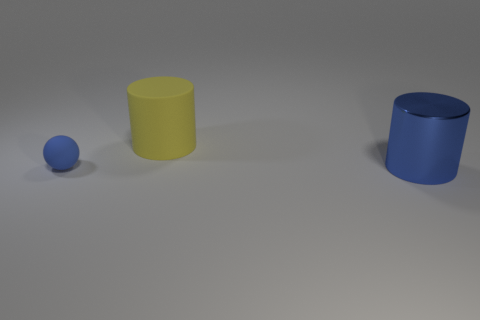Add 3 tiny objects. How many objects exist? 6 Add 2 small blue spheres. How many small blue spheres are left? 3 Add 2 large blue metallic things. How many large blue metallic things exist? 3 Subtract 0 green balls. How many objects are left? 3 Subtract all spheres. How many objects are left? 2 Subtract all yellow balls. Subtract all yellow cylinders. How many balls are left? 1 Subtract all red blocks. How many green balls are left? 0 Subtract all cyan cubes. Subtract all shiny cylinders. How many objects are left? 2 